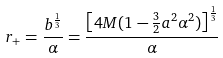Convert formula to latex. <formula><loc_0><loc_0><loc_500><loc_500>r _ { + } = \frac { b ^ { \frac { 1 } { 3 } } } { \alpha } = \frac { \left [ 4 M ( 1 - \frac { 3 } { 2 } a ^ { 2 } \alpha ^ { 2 } ) \right ] ^ { \frac { 1 } { 3 } } } { \alpha }</formula> 